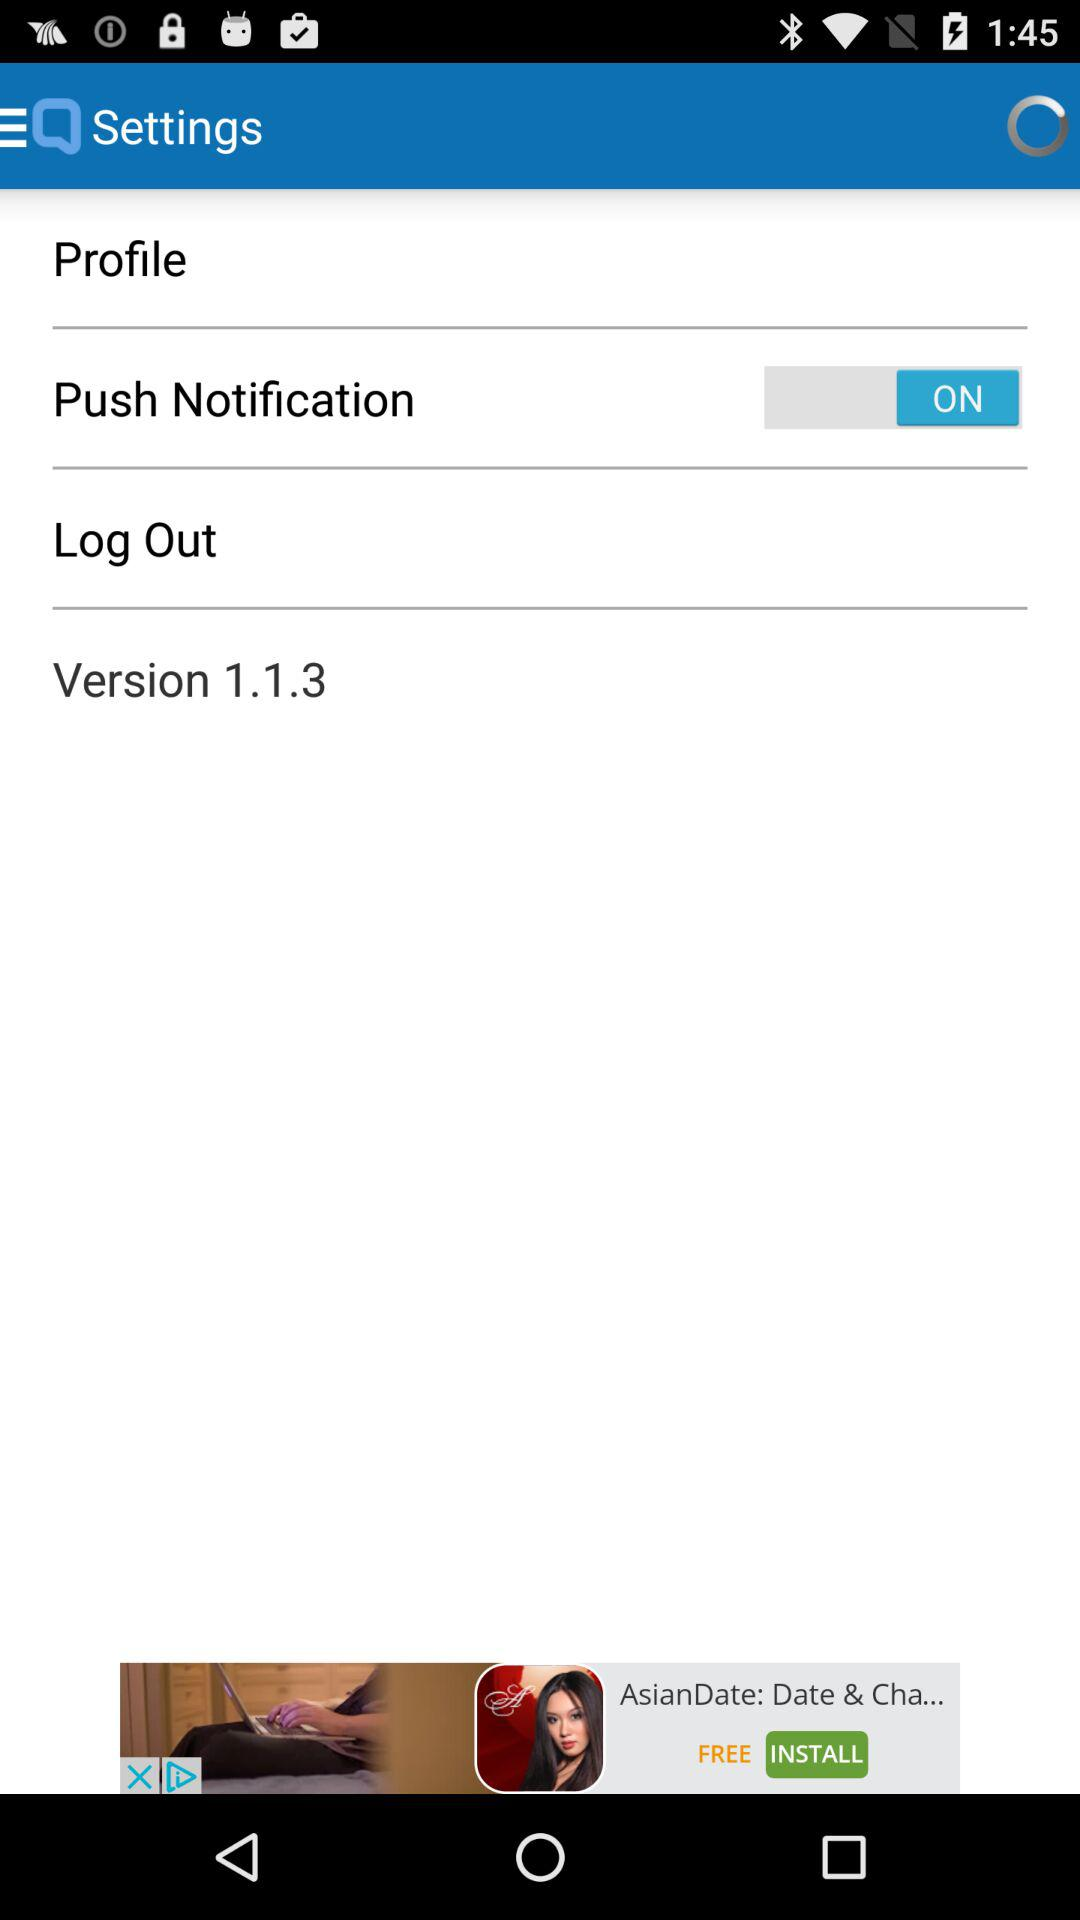What is the version of the application? The version of the application is 1.1.3. 